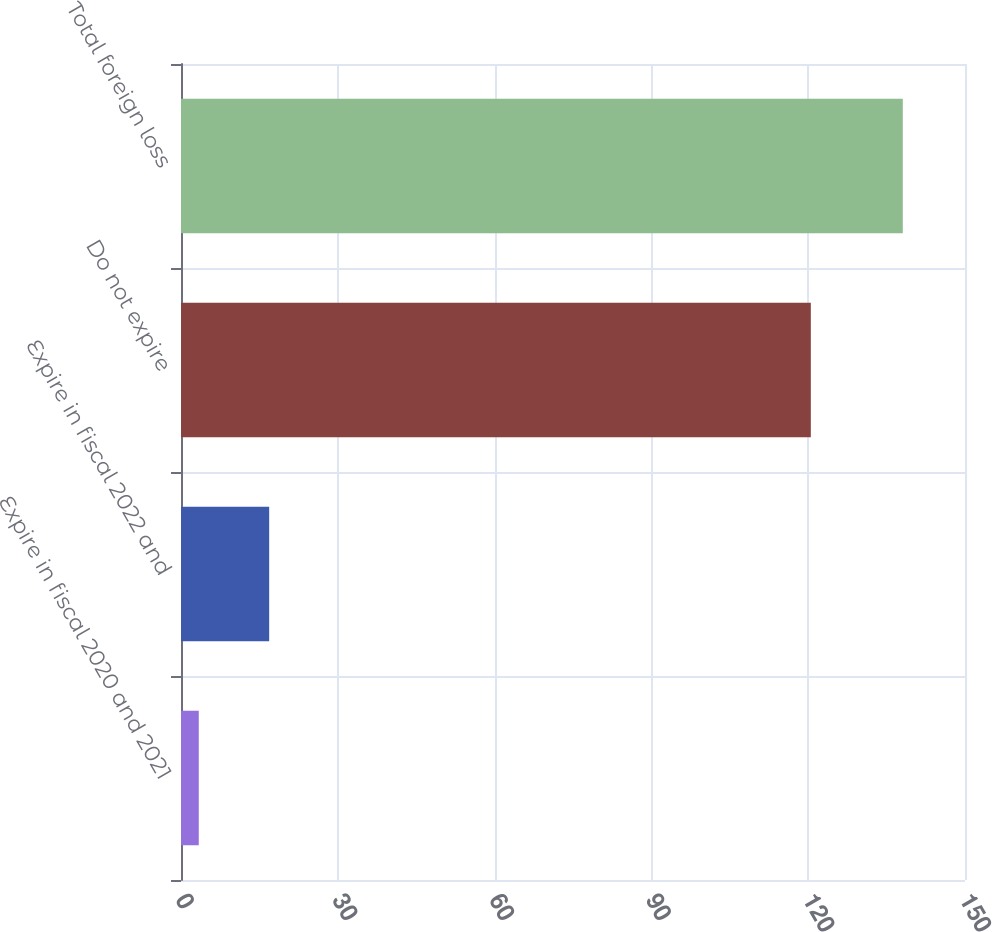Convert chart to OTSL. <chart><loc_0><loc_0><loc_500><loc_500><bar_chart><fcel>Expire in fiscal 2020 and 2021<fcel>Expire in fiscal 2022 and<fcel>Do not expire<fcel>Total foreign loss<nl><fcel>3.4<fcel>16.87<fcel>120.5<fcel>138.1<nl></chart> 